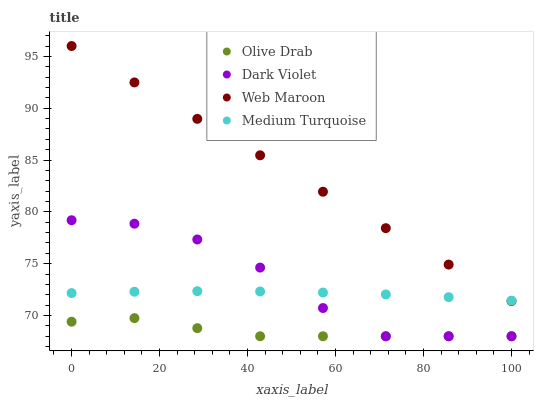Does Olive Drab have the minimum area under the curve?
Answer yes or no. Yes. Does Web Maroon have the maximum area under the curve?
Answer yes or no. Yes. Does Dark Violet have the minimum area under the curve?
Answer yes or no. No. Does Dark Violet have the maximum area under the curve?
Answer yes or no. No. Is Web Maroon the smoothest?
Answer yes or no. Yes. Is Dark Violet the roughest?
Answer yes or no. Yes. Is Dark Violet the smoothest?
Answer yes or no. No. Is Web Maroon the roughest?
Answer yes or no. No. Does Dark Violet have the lowest value?
Answer yes or no. Yes. Does Web Maroon have the lowest value?
Answer yes or no. No. Does Web Maroon have the highest value?
Answer yes or no. Yes. Does Dark Violet have the highest value?
Answer yes or no. No. Is Dark Violet less than Web Maroon?
Answer yes or no. Yes. Is Web Maroon greater than Olive Drab?
Answer yes or no. Yes. Does Dark Violet intersect Olive Drab?
Answer yes or no. Yes. Is Dark Violet less than Olive Drab?
Answer yes or no. No. Is Dark Violet greater than Olive Drab?
Answer yes or no. No. Does Dark Violet intersect Web Maroon?
Answer yes or no. No. 